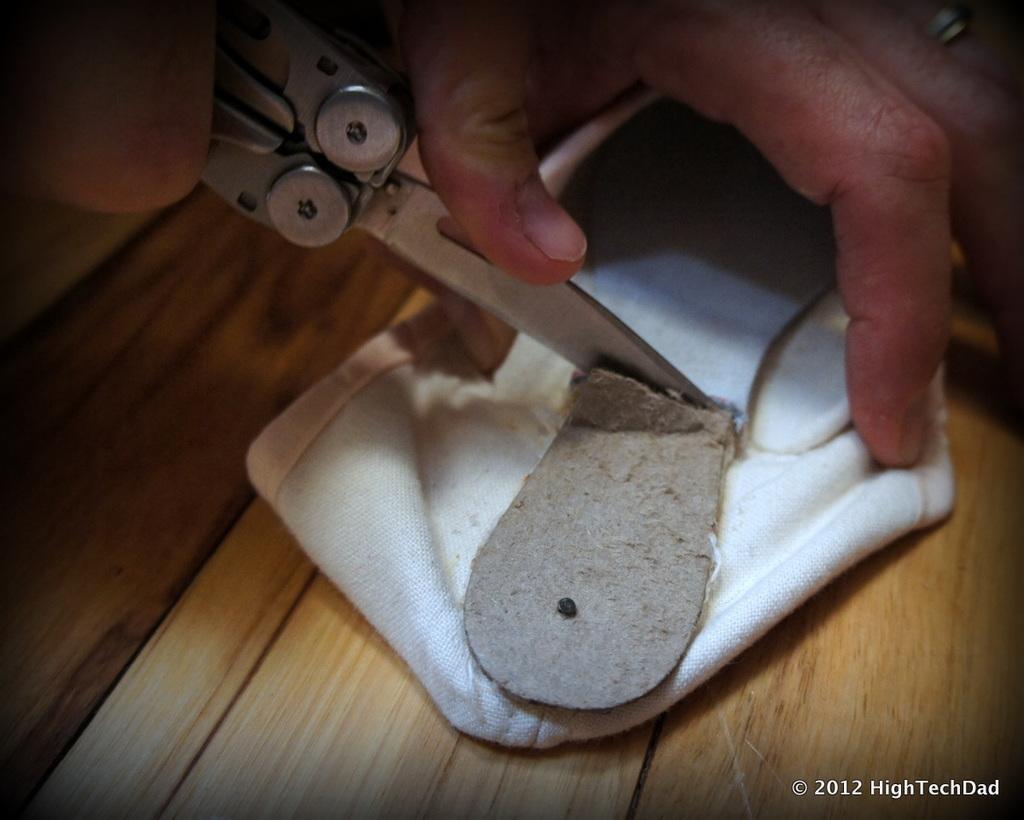How would you summarize this image in a sentence or two? In this image there is one hand at top of this image and holding a scissor and there is a white color cloth at middle of this image and there is one object is at bottom of this image and this cloth is kept on one table and there is one watermark at bottom right corner of this image. 